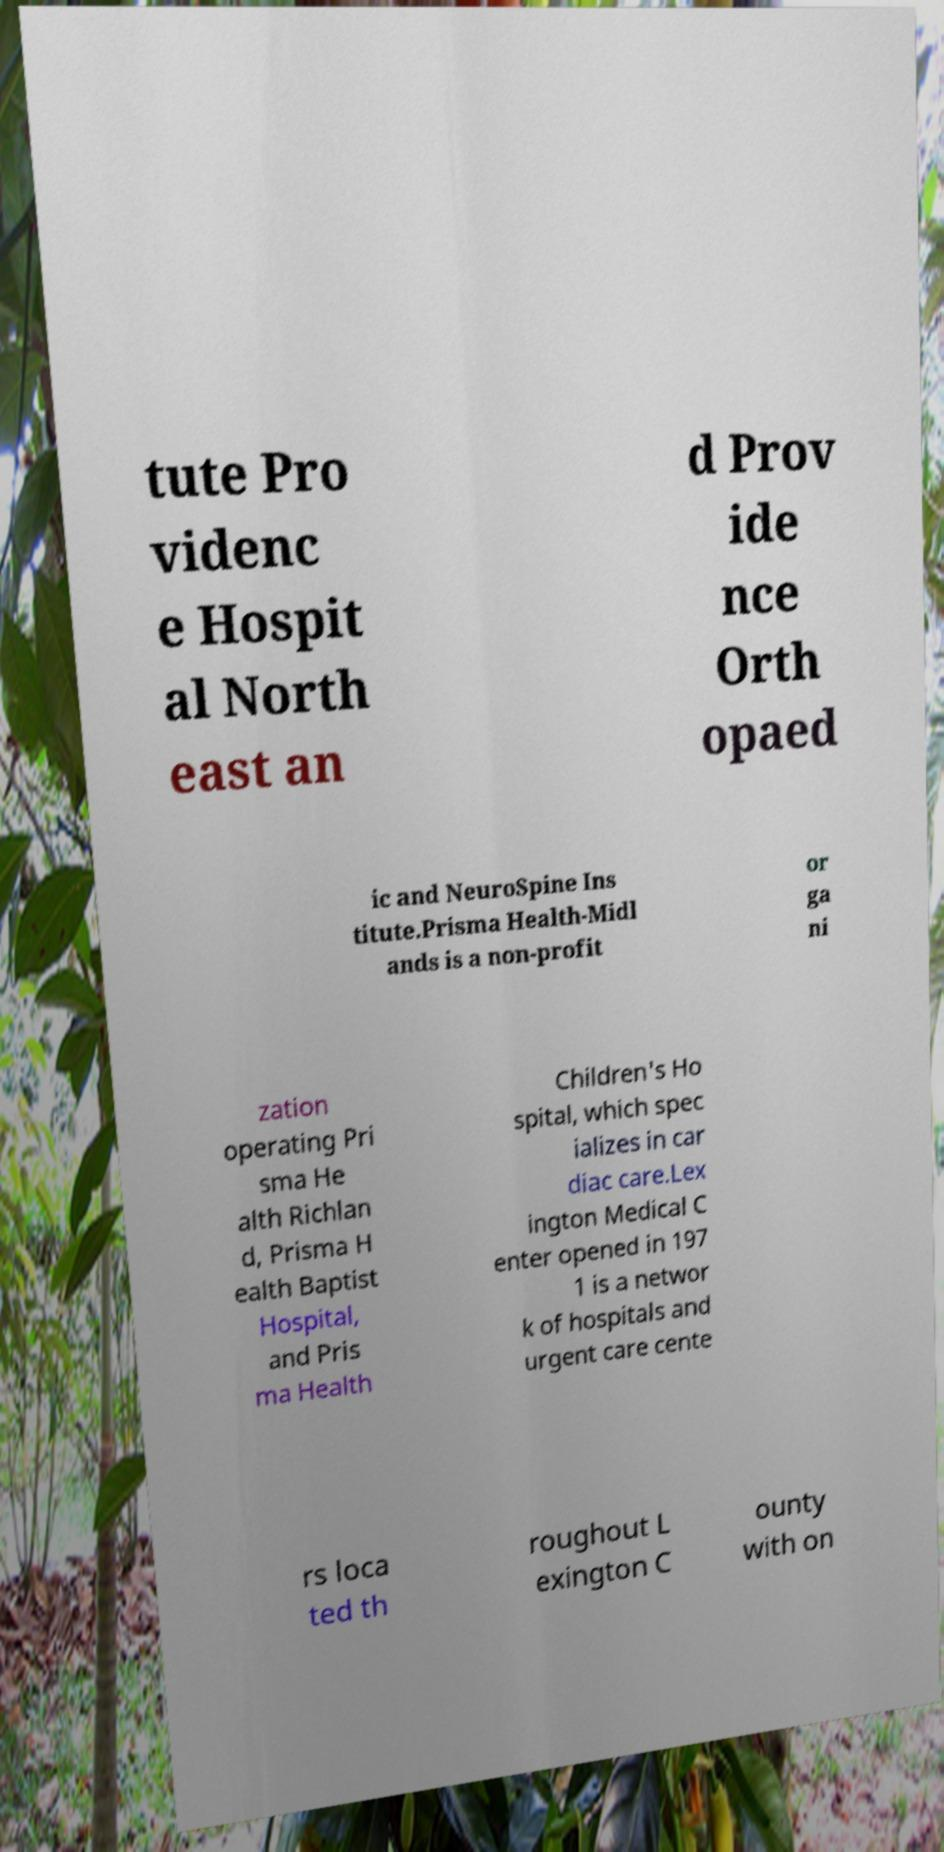Can you read and provide the text displayed in the image?This photo seems to have some interesting text. Can you extract and type it out for me? tute Pro videnc e Hospit al North east an d Prov ide nce Orth opaed ic and NeuroSpine Ins titute.Prisma Health-Midl ands is a non-profit or ga ni zation operating Pri sma He alth Richlan d, Prisma H ealth Baptist Hospital, and Pris ma Health Children's Ho spital, which spec ializes in car diac care.Lex ington Medical C enter opened in 197 1 is a networ k of hospitals and urgent care cente rs loca ted th roughout L exington C ounty with on 